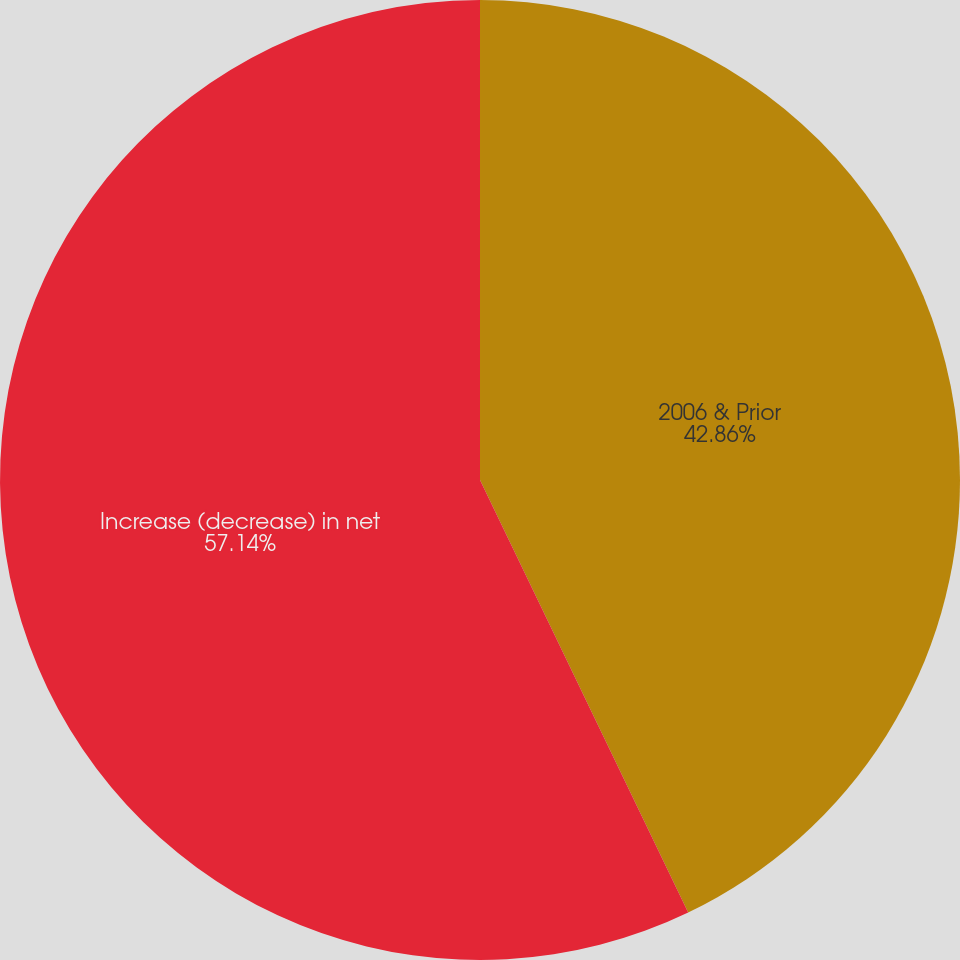Convert chart. <chart><loc_0><loc_0><loc_500><loc_500><pie_chart><fcel>2006 & Prior<fcel>Increase (decrease) in net<nl><fcel>42.86%<fcel>57.14%<nl></chart> 